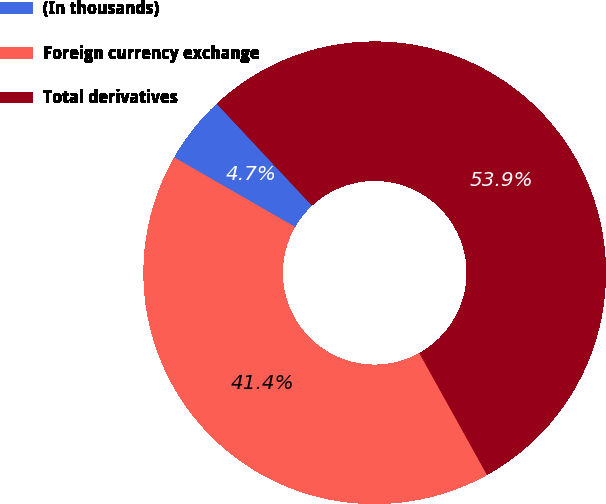Convert chart. <chart><loc_0><loc_0><loc_500><loc_500><pie_chart><fcel>(In thousands)<fcel>Foreign currency exchange<fcel>Total derivatives<nl><fcel>4.73%<fcel>41.38%<fcel>53.89%<nl></chart> 